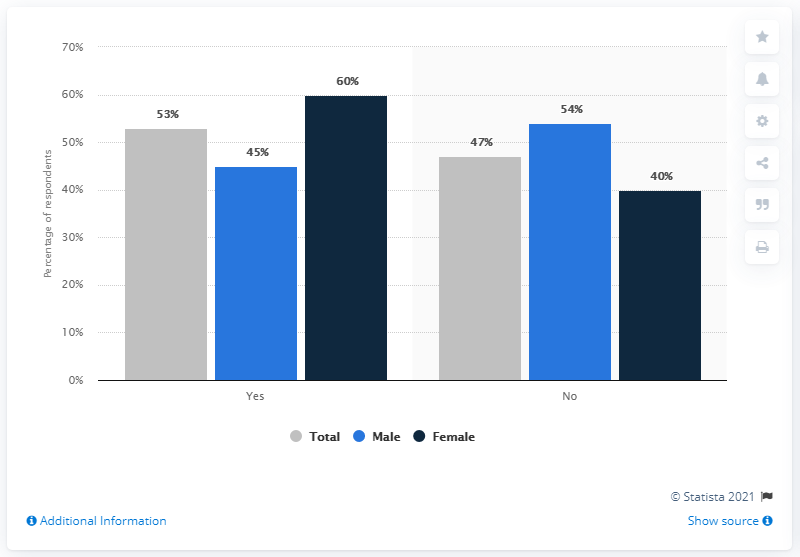Specify some key components in this picture. According to data from 2018, approximately 53% of U.S. adults had tried vaping or using electronic cigarettes. According to the survey, 40% of the respondents who replied with "No" were female. Out of all respondents, 53% stated 'yes'. 